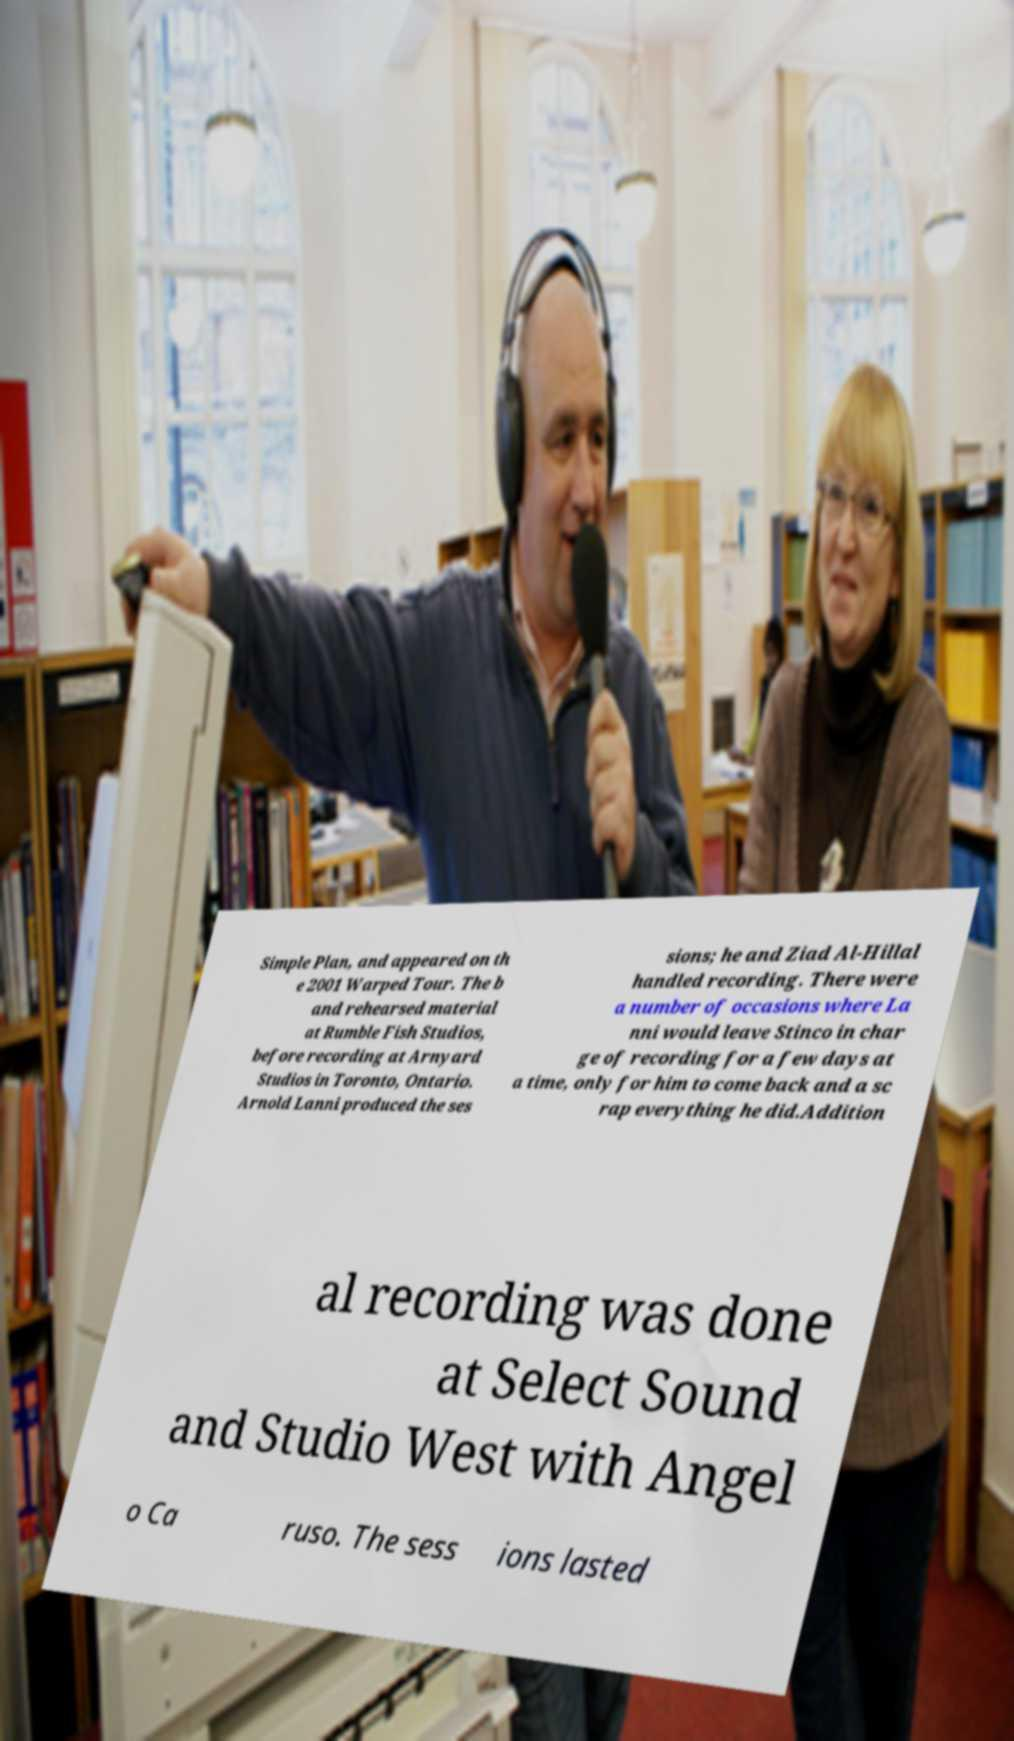For documentation purposes, I need the text within this image transcribed. Could you provide that? Simple Plan, and appeared on th e 2001 Warped Tour. The b and rehearsed material at Rumble Fish Studios, before recording at Arnyard Studios in Toronto, Ontario. Arnold Lanni produced the ses sions; he and Ziad Al-Hillal handled recording. There were a number of occasions where La nni would leave Stinco in char ge of recording for a few days at a time, only for him to come back and a sc rap everything he did.Addition al recording was done at Select Sound and Studio West with Angel o Ca ruso. The sess ions lasted 